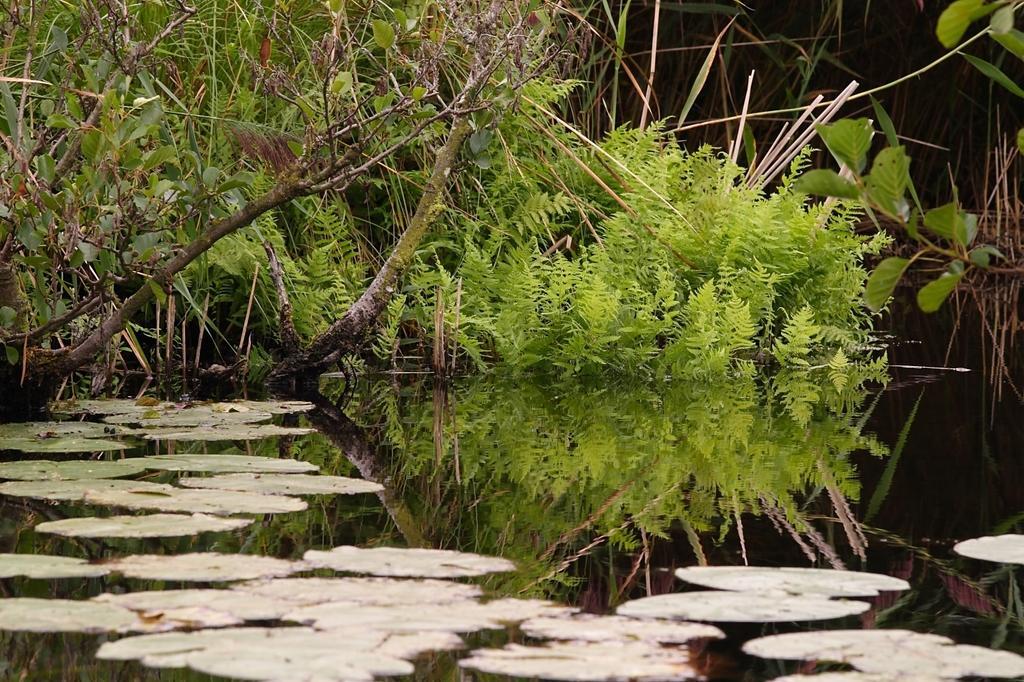Could you give a brief overview of what you see in this image? In this image there are leaves on the water , and in the background there are plants. 